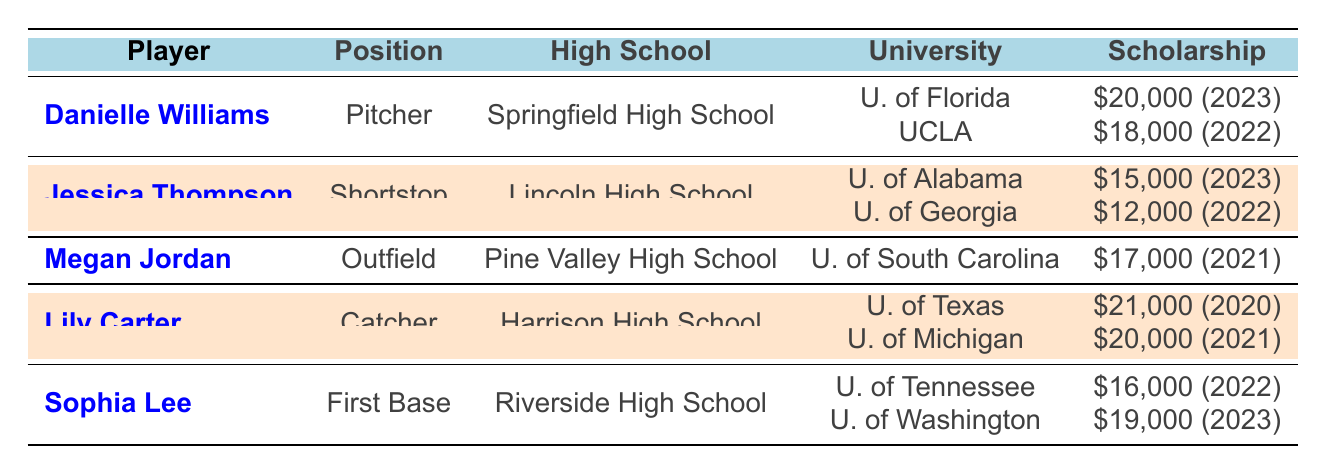Which university offered the highest scholarship to Danielle Williams? The table lists two scholarship offers for Danielle Williams. The University of Florida offered $20,000, and UCLA offered $18,000. Thus, the highest scholarship offer is $20,000 from the University of Florida.
Answer: $20,000 How many scholarship offers did Jessica Thompson receive? The table shows Jessica Thompson received two scholarship offers: one from the University of Alabama and another from the University of Georgia. Therefore, she received a total of 2 scholarship offers.
Answer: 2 Did Megan Jordan accept any scholarship offers? The table indicates that Megan Jordan received one scholarship offer from the University of South Carolina, which she declined. Since she has not accepted any, the answer is no.
Answer: No What is the total amount of scholarships offered to Lily Carter? The table lists two scholarship offers for Lily Carter: $21,000 from the University of Texas and $20,000 from the University of Michigan. Adding these amounts together gives a total of $21,000 + $20,000 = $41,000.
Answer: $41,000 Which player received the most scholarship offers in 2022? Looking at the table, Danielle Williams declined the offer from UCLA in 2022, Jessica Thompson accepted offers from Alabama and Georgia, and Sophia Lee accepted an offer from Tennessee. Since both Danielle Williams and Jessica Thompson have 2 offers in total but for different years, Jessica Thompson received the most offers overall.
Answer: Jessica Thompson What was the average scholarship amount received by Sophia Lee? Sophia Lee received two scholarship offers of $16,000 and $19,000. The average is calculated by adding the two offers ($16,000 + $19,000 = $35,000) and dividing by the number of offers (2). Thus, the average is $35,000 / 2 = $17,500.
Answer: $17,500 Did any player receive a scholarship offer from the University of California, Los Angeles? The table shows Danielle Williams received an offer from UCLA, which she declined. Therefore, the answer to the question is yes.
Answer: Yes What is the difference between the highest and lowest scholarship amounts offered to players in the table? The highest scholarship amount is $21,000 offered to Lily Carter by the University of Texas, and the lowest is $12,000 offered to Jessica Thompson by the University of Georgia. The difference is $21,000 - $12,000 = $9,000.
Answer: $9,000 Which position had the most players receiving scholarship offers? Analyzing the table, there are 5 players and the positions are: Pitcher (Danielle Williams), Shortstop (Jessica Thompson), Outfield (Megan Jordan), Catcher (Lily Carter), and First Base (Sophia Lee). Since each position has only 1 player, no single position had multiple players receiving offers. Hence, there is no tied position with more than one offer.
Answer: None 